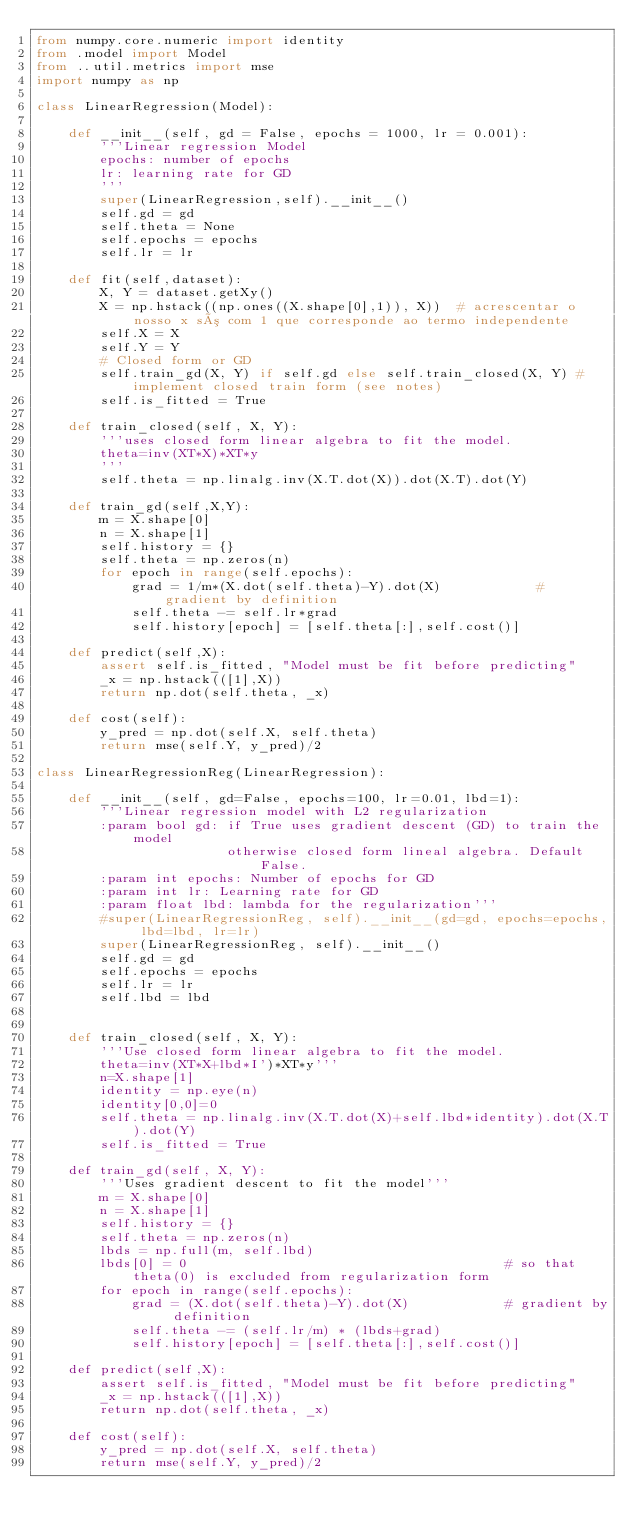Convert code to text. <code><loc_0><loc_0><loc_500><loc_500><_Python_>from numpy.core.numeric import identity
from .model import Model
from ..util.metrics import mse
import numpy as np

class LinearRegression(Model):

    def __init__(self, gd = False, epochs = 1000, lr = 0.001):
        '''Linear regression Model
        epochs: number of epochs 
        lr: learning rate for GD
        '''
        super(LinearRegression,self).__init__()
        self.gd = gd
        self.theta = None
        self.epochs = epochs
        self.lr = lr

    def fit(self,dataset):
        X, Y = dataset.getXy()
        X = np.hstack((np.ones((X.shape[0],1)), X))  # acrescentar o nosso x só com 1 que corresponde ao termo independente
        self.X = X
        self.Y = Y
        # Closed form or GD
        self.train_gd(X, Y) if self.gd else self.train_closed(X, Y) # implement closed train form (see notes)
        self.is_fitted = True
    
    def train_closed(self, X, Y):
        '''uses closed form linear algebra to fit the model.
        theta=inv(XT*X)*XT*y
        '''
        self.theta = np.linalg.inv(X.T.dot(X)).dot(X.T).dot(Y)
        
    def train_gd(self,X,Y):
        m = X.shape[0]
        n = X.shape[1]
        self.history = {}
        self.theta = np.zeros(n)
        for epoch in range(self.epochs):
            grad = 1/m*(X.dot(self.theta)-Y).dot(X)            # gradient by definition
            self.theta -= self.lr*grad
            self.history[epoch] = [self.theta[:],self.cost()]
    
    def predict(self,X):
        assert self.is_fitted, "Model must be fit before predicting"
        _x = np.hstack(([1],X))
        return np.dot(self.theta, _x)

    def cost(self):
        y_pred = np.dot(self.X, self.theta)
        return mse(self.Y, y_pred)/2

class LinearRegressionReg(LinearRegression):

    def __init__(self, gd=False, epochs=100, lr=0.01, lbd=1):
        '''Linear regression model with L2 regularization
        :param bool gd: if True uses gradient descent (GD) to train the model
                        otherwise closed form lineal algebra. Default False.
        :param int epochs: Number of epochs for GD
        :param int lr: Learning rate for GD
        :param float lbd: lambda for the regularization'''
        #super(LinearRegressionReg, self).__init__(gd=gd, epochs=epochs, lbd=lbd, lr=lr)
        super(LinearRegressionReg, self).__init__()
        self.gd = gd
        self.epochs = epochs
        self.lr = lr
        self.lbd = lbd
        

    def train_closed(self, X, Y):
        '''Use closed form linear algebra to fit the model.
        theta=inv(XT*X+lbd*I')*XT*y'''
        n=X.shape[1]
        identity = np.eye(n)
        identity[0,0]=0
        self.theta = np.linalg.inv(X.T.dot(X)+self.lbd*identity).dot(X.T).dot(Y)
        self.is_fitted = True

    def train_gd(self, X, Y):
        '''Uses gradient descent to fit the model'''
        m = X.shape[0]
        n = X.shape[1]
        self.history = {}
        self.theta = np.zeros(n)
        lbds = np.full(m, self.lbd)
        lbds[0] = 0                                        # so that theta(0) is excluded from regularization form
        for epoch in range(self.epochs):
            grad = (X.dot(self.theta)-Y).dot(X)            # gradient by definition
            self.theta -= (self.lr/m) * (lbds+grad)
            self.history[epoch] = [self.theta[:],self.cost()]

    def predict(self,X):
        assert self.is_fitted, "Model must be fit before predicting"
        _x = np.hstack(([1],X))
        return np.dot(self.theta, _x)

    def cost(self):
        y_pred = np.dot(self.X, self.theta)
        return mse(self.Y, y_pred)/2



</code> 